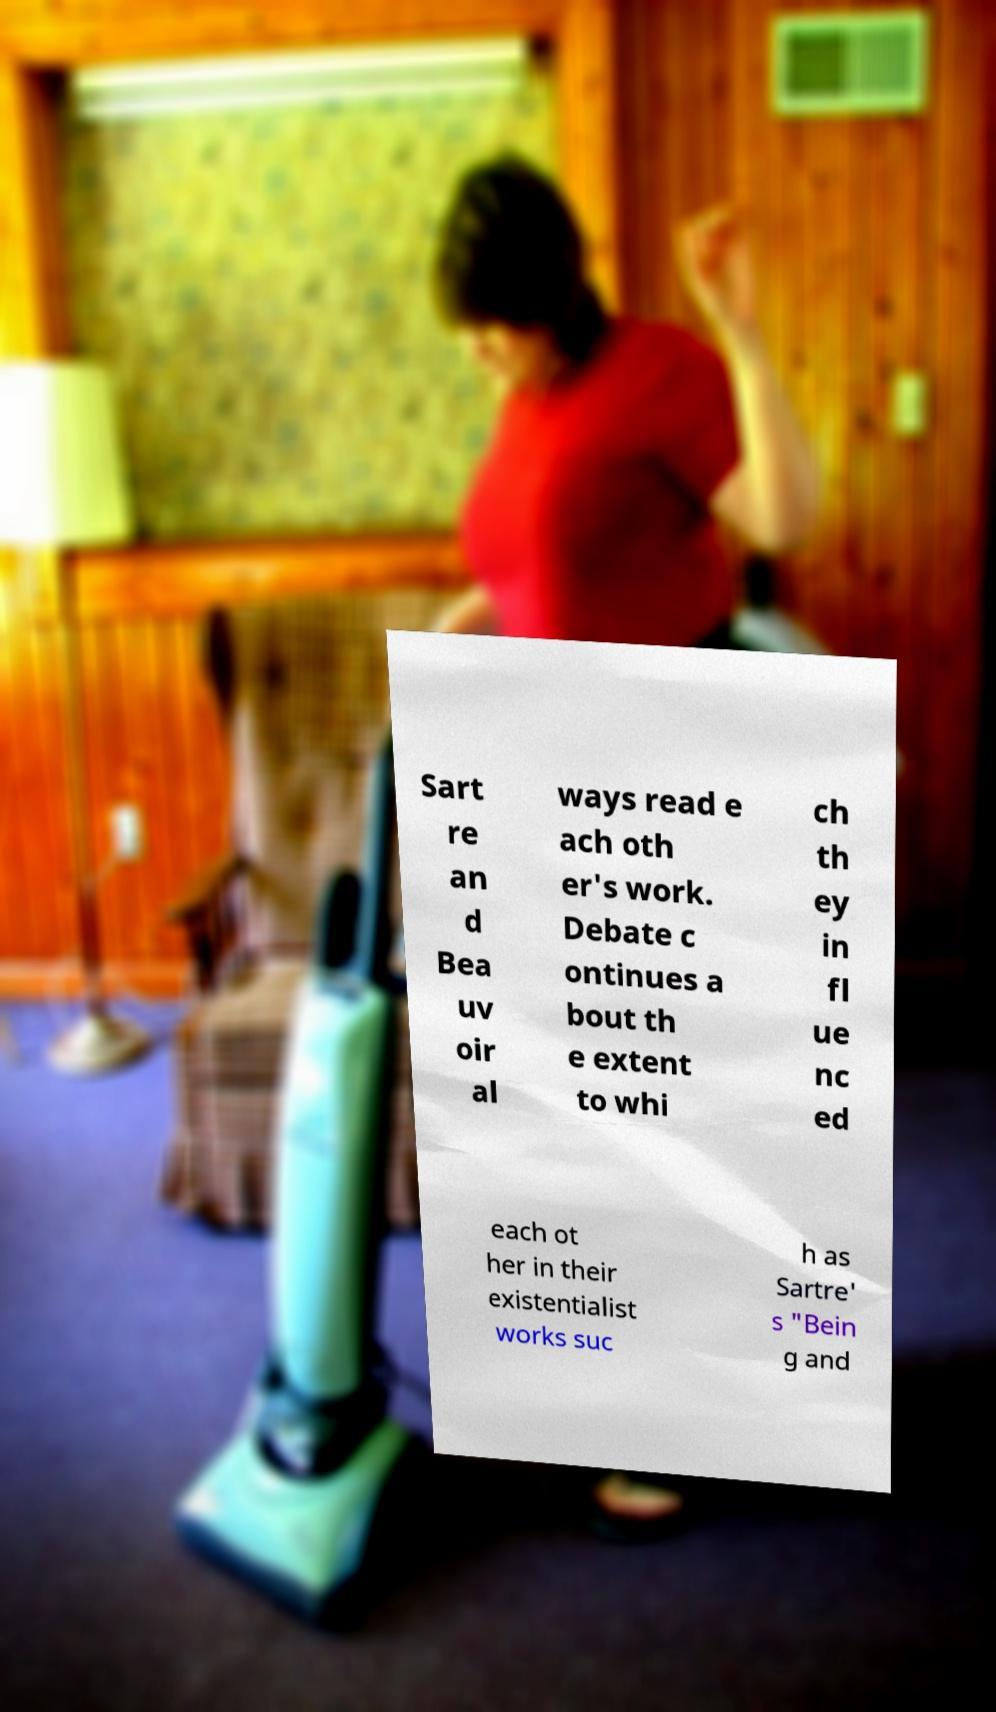What messages or text are displayed in this image? I need them in a readable, typed format. Sart re an d Bea uv oir al ways read e ach oth er's work. Debate c ontinues a bout th e extent to whi ch th ey in fl ue nc ed each ot her in their existentialist works suc h as Sartre' s "Bein g and 